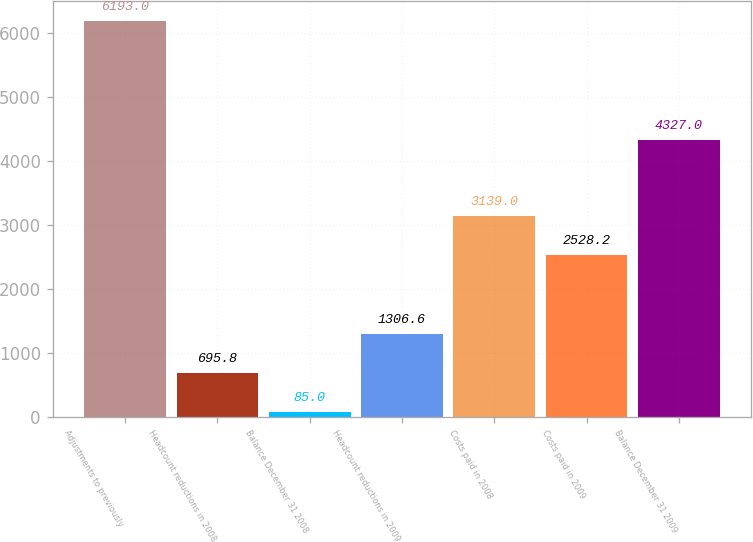<chart> <loc_0><loc_0><loc_500><loc_500><bar_chart><fcel>Adjustments to previously<fcel>Headcount reductions in 2008<fcel>Balance December 31 2008<fcel>Headcount reductions in 2009<fcel>Costs paid in 2008<fcel>Costs paid in 2009<fcel>Balance December 31 2009<nl><fcel>6193<fcel>695.8<fcel>85<fcel>1306.6<fcel>3139<fcel>2528.2<fcel>4327<nl></chart> 